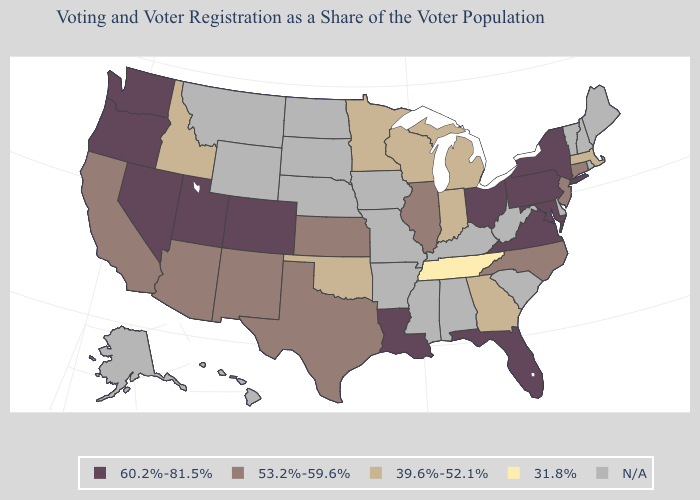Which states have the lowest value in the USA?
Keep it brief. Tennessee. Name the states that have a value in the range 60.2%-81.5%?
Write a very short answer. Colorado, Florida, Louisiana, Maryland, Nevada, New York, Ohio, Oregon, Pennsylvania, Utah, Virginia, Washington. Which states hav the highest value in the MidWest?
Keep it brief. Ohio. Which states have the lowest value in the MidWest?
Give a very brief answer. Indiana, Michigan, Minnesota, Wisconsin. What is the lowest value in the USA?
Give a very brief answer. 31.8%. What is the value of Connecticut?
Be succinct. 53.2%-59.6%. What is the value of Utah?
Concise answer only. 60.2%-81.5%. Among the states that border Pennsylvania , does New Jersey have the highest value?
Answer briefly. No. Name the states that have a value in the range 39.6%-52.1%?
Quick response, please. Georgia, Idaho, Indiana, Massachusetts, Michigan, Minnesota, Oklahoma, Wisconsin. Does Virginia have the highest value in the USA?
Keep it brief. Yes. Name the states that have a value in the range 31.8%?
Be succinct. Tennessee. Name the states that have a value in the range 60.2%-81.5%?
Keep it brief. Colorado, Florida, Louisiana, Maryland, Nevada, New York, Ohio, Oregon, Pennsylvania, Utah, Virginia, Washington. Which states have the lowest value in the USA?
Write a very short answer. Tennessee. Name the states that have a value in the range 60.2%-81.5%?
Give a very brief answer. Colorado, Florida, Louisiana, Maryland, Nevada, New York, Ohio, Oregon, Pennsylvania, Utah, Virginia, Washington. 